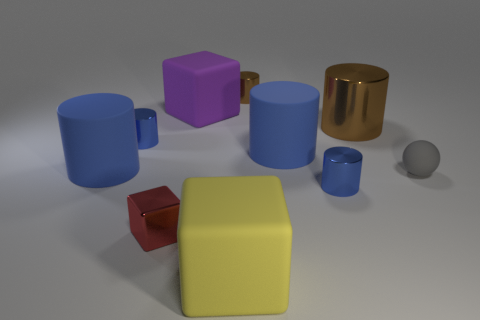How many blue cylinders must be subtracted to get 1 blue cylinders? 3 Subtract all large cubes. How many cubes are left? 1 Subtract all blue cylinders. How many cylinders are left? 2 Subtract 3 cylinders. How many cylinders are left? 3 Subtract 0 yellow cylinders. How many objects are left? 10 Subtract all spheres. How many objects are left? 9 Subtract all cyan blocks. Subtract all cyan balls. How many blocks are left? 3 Subtract all gray spheres. How many cyan blocks are left? 0 Subtract all big purple blocks. Subtract all small red blocks. How many objects are left? 8 Add 4 tiny blue cylinders. How many tiny blue cylinders are left? 6 